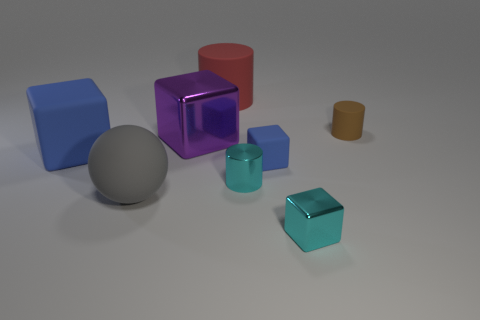Add 1 small blue metal cylinders. How many objects exist? 9 Subtract all cyan cubes. How many cubes are left? 3 Subtract all cyan cubes. How many cubes are left? 3 Subtract 1 cylinders. How many cylinders are left? 2 Subtract 2 blue cubes. How many objects are left? 6 Subtract all cylinders. How many objects are left? 5 Subtract all red balls. Subtract all brown blocks. How many balls are left? 1 Subtract all red balls. How many brown cylinders are left? 1 Subtract all big cyan shiny balls. Subtract all cyan metallic objects. How many objects are left? 6 Add 5 tiny blue cubes. How many tiny blue cubes are left? 6 